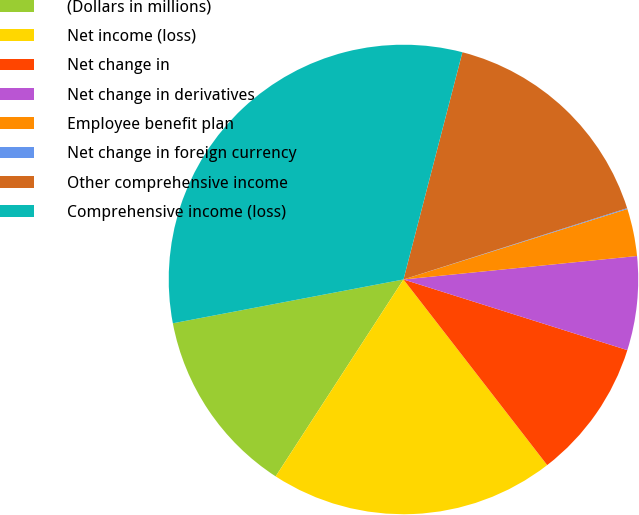Convert chart. <chart><loc_0><loc_0><loc_500><loc_500><pie_chart><fcel>(Dollars in millions)<fcel>Net income (loss)<fcel>Net change in<fcel>Net change in derivatives<fcel>Employee benefit plan<fcel>Net change in foreign currency<fcel>Other comprehensive income<fcel>Comprehensive income (loss)<nl><fcel>12.85%<fcel>19.65%<fcel>9.65%<fcel>6.46%<fcel>3.26%<fcel>0.06%<fcel>16.05%<fcel>32.03%<nl></chart> 